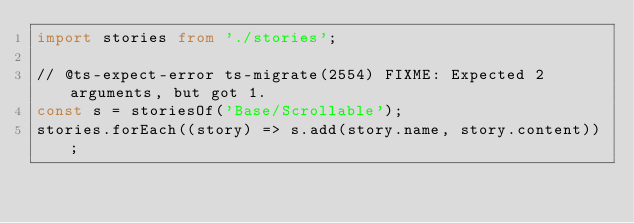<code> <loc_0><loc_0><loc_500><loc_500><_TypeScript_>import stories from './stories';

// @ts-expect-error ts-migrate(2554) FIXME: Expected 2 arguments, but got 1.
const s = storiesOf('Base/Scrollable');
stories.forEach((story) => s.add(story.name, story.content));
</code> 